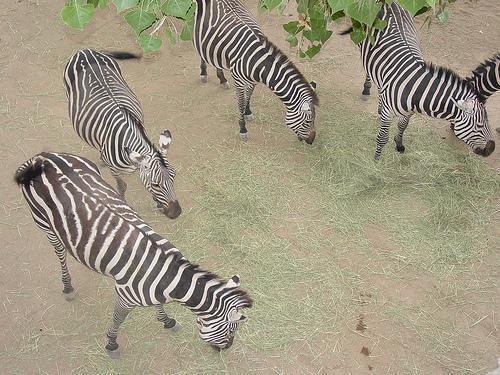How many zebras are here?
Give a very brief answer. 5. 